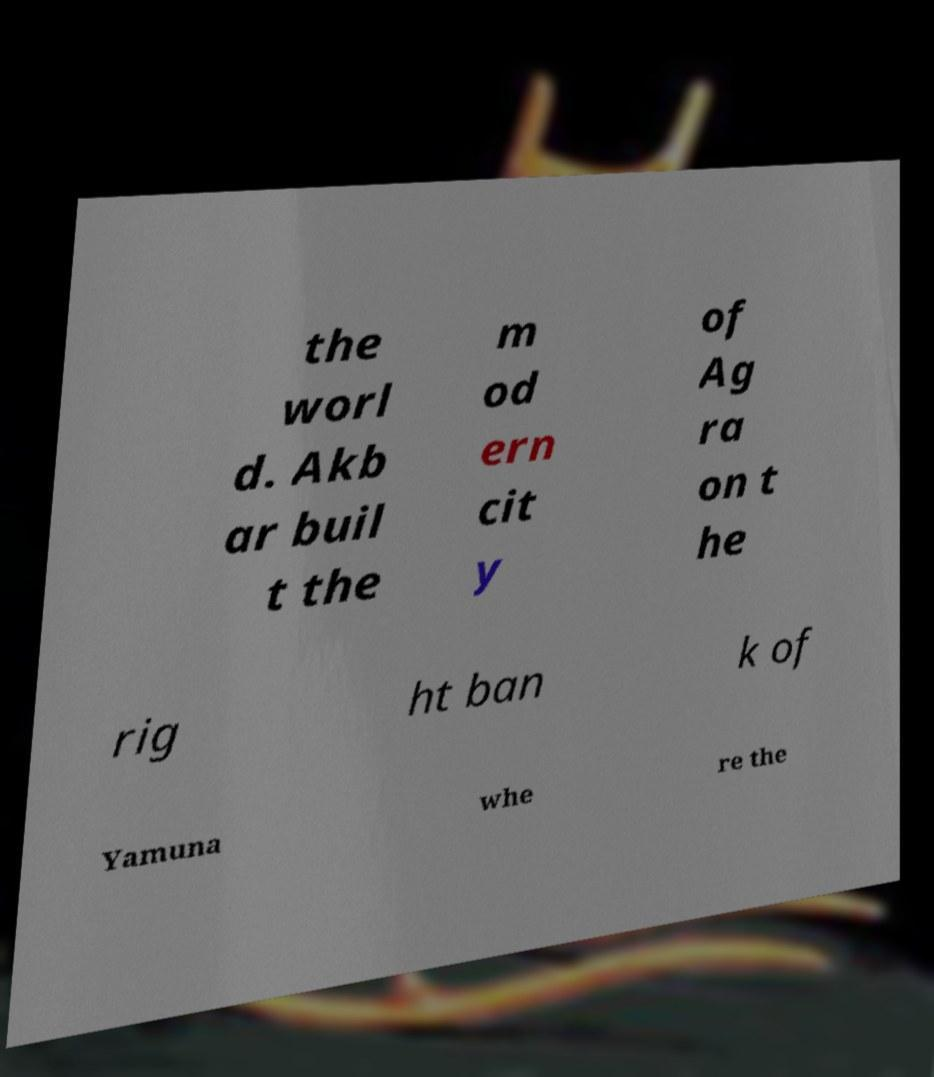Please identify and transcribe the text found in this image. the worl d. Akb ar buil t the m od ern cit y of Ag ra on t he rig ht ban k of Yamuna whe re the 